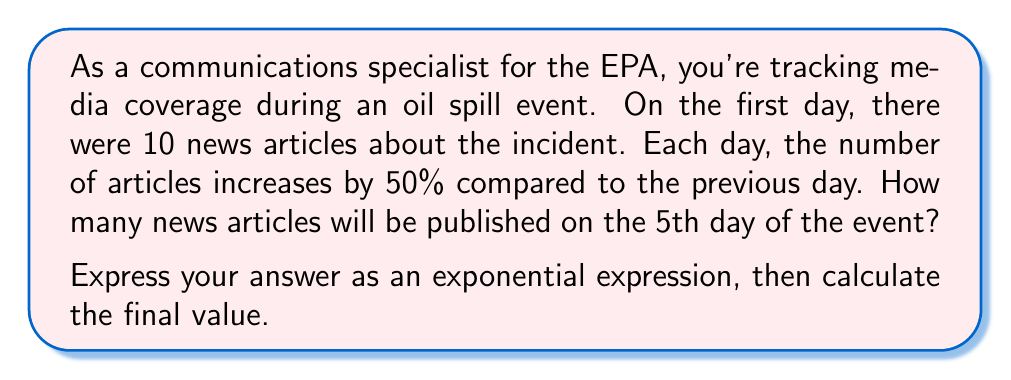Can you solve this math problem? Let's approach this step-by-step:

1) We start with 10 articles on day 1.

2) Each day, the number increases by 50%, which means it's multiplied by 1.5.

3) We can express this as an exponential function:
   $10 \cdot 1.5^{n-1}$, where $n$ is the number of days.

4) We want to know the number of articles on the 5th day, so $n = 5$.

5) Let's substitute this into our expression:
   $10 \cdot 1.5^{5-1} = 10 \cdot 1.5^4$

6) Now, let's calculate $1.5^4$:
   $$1.5^4 = 1.5 \cdot 1.5 \cdot 1.5 \cdot 1.5 = 5.0625$$

7) Finally, we multiply by 10:
   $10 \cdot 5.0625 = 50.625$

8) Since we're dealing with whole articles, we round to the nearest integer: 51.
Answer: $10 \cdot 1.5^4 = 51$ articles 